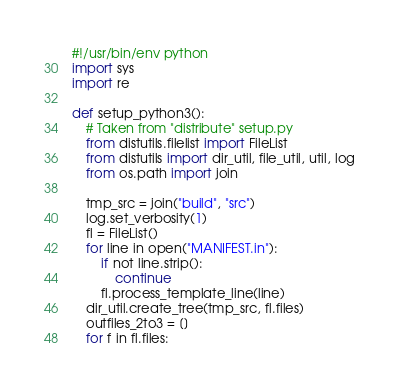Convert code to text. <code><loc_0><loc_0><loc_500><loc_500><_Python_>#!/usr/bin/env python
import sys
import re

def setup_python3():
    # Taken from "distribute" setup.py
    from distutils.filelist import FileList
    from distutils import dir_util, file_util, util, log
    from os.path import join
  
    tmp_src = join("build", "src")
    log.set_verbosity(1)
    fl = FileList()
    for line in open("MANIFEST.in"):
        if not line.strip():
            continue
        fl.process_template_line(line)
    dir_util.create_tree(tmp_src, fl.files)
    outfiles_2to3 = []
    for f in fl.files:</code> 